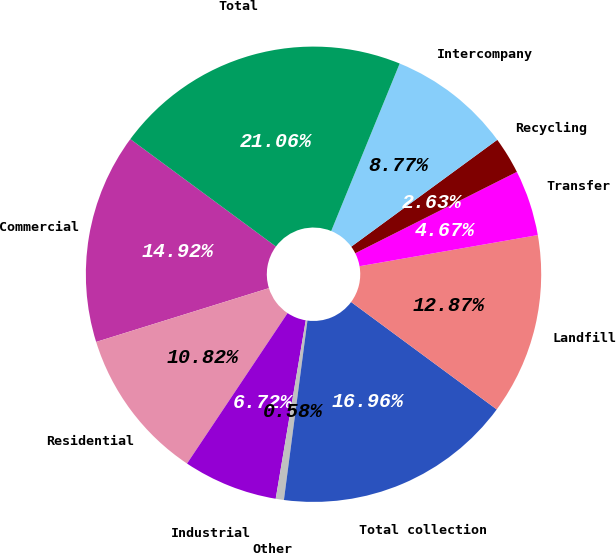<chart> <loc_0><loc_0><loc_500><loc_500><pie_chart><fcel>Commercial<fcel>Residential<fcel>Industrial<fcel>Other<fcel>Total collection<fcel>Landfill<fcel>Transfer<fcel>Recycling<fcel>Intercompany<fcel>Total<nl><fcel>14.92%<fcel>10.82%<fcel>6.72%<fcel>0.58%<fcel>16.96%<fcel>12.87%<fcel>4.67%<fcel>2.63%<fcel>8.77%<fcel>21.06%<nl></chart> 